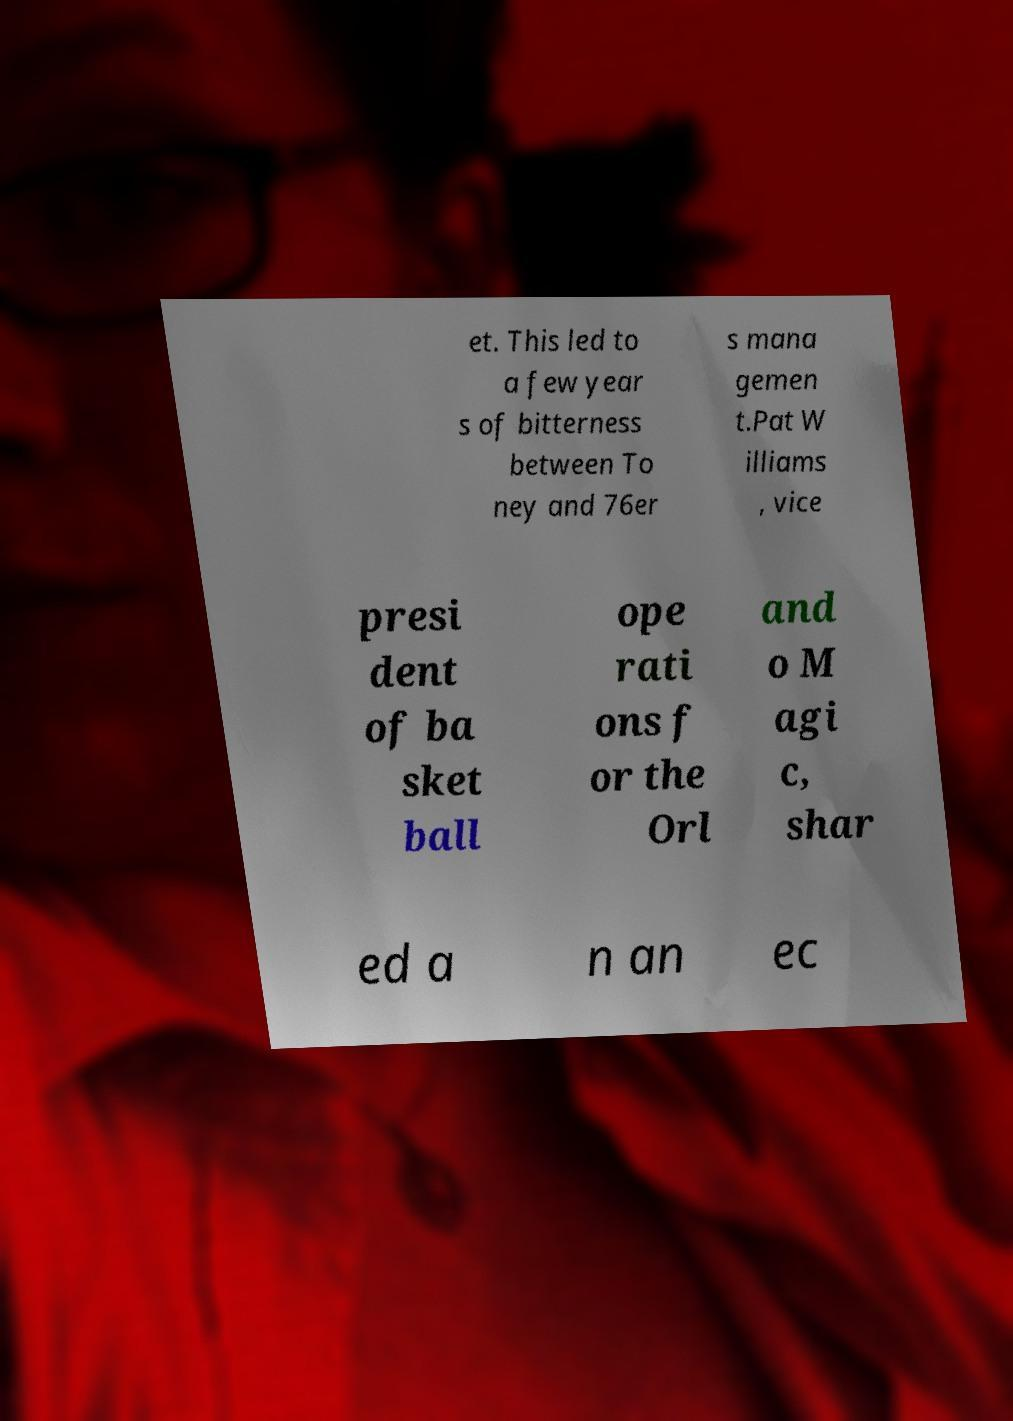I need the written content from this picture converted into text. Can you do that? et. This led to a few year s of bitterness between To ney and 76er s mana gemen t.Pat W illiams , vice presi dent of ba sket ball ope rati ons f or the Orl and o M agi c, shar ed a n an ec 